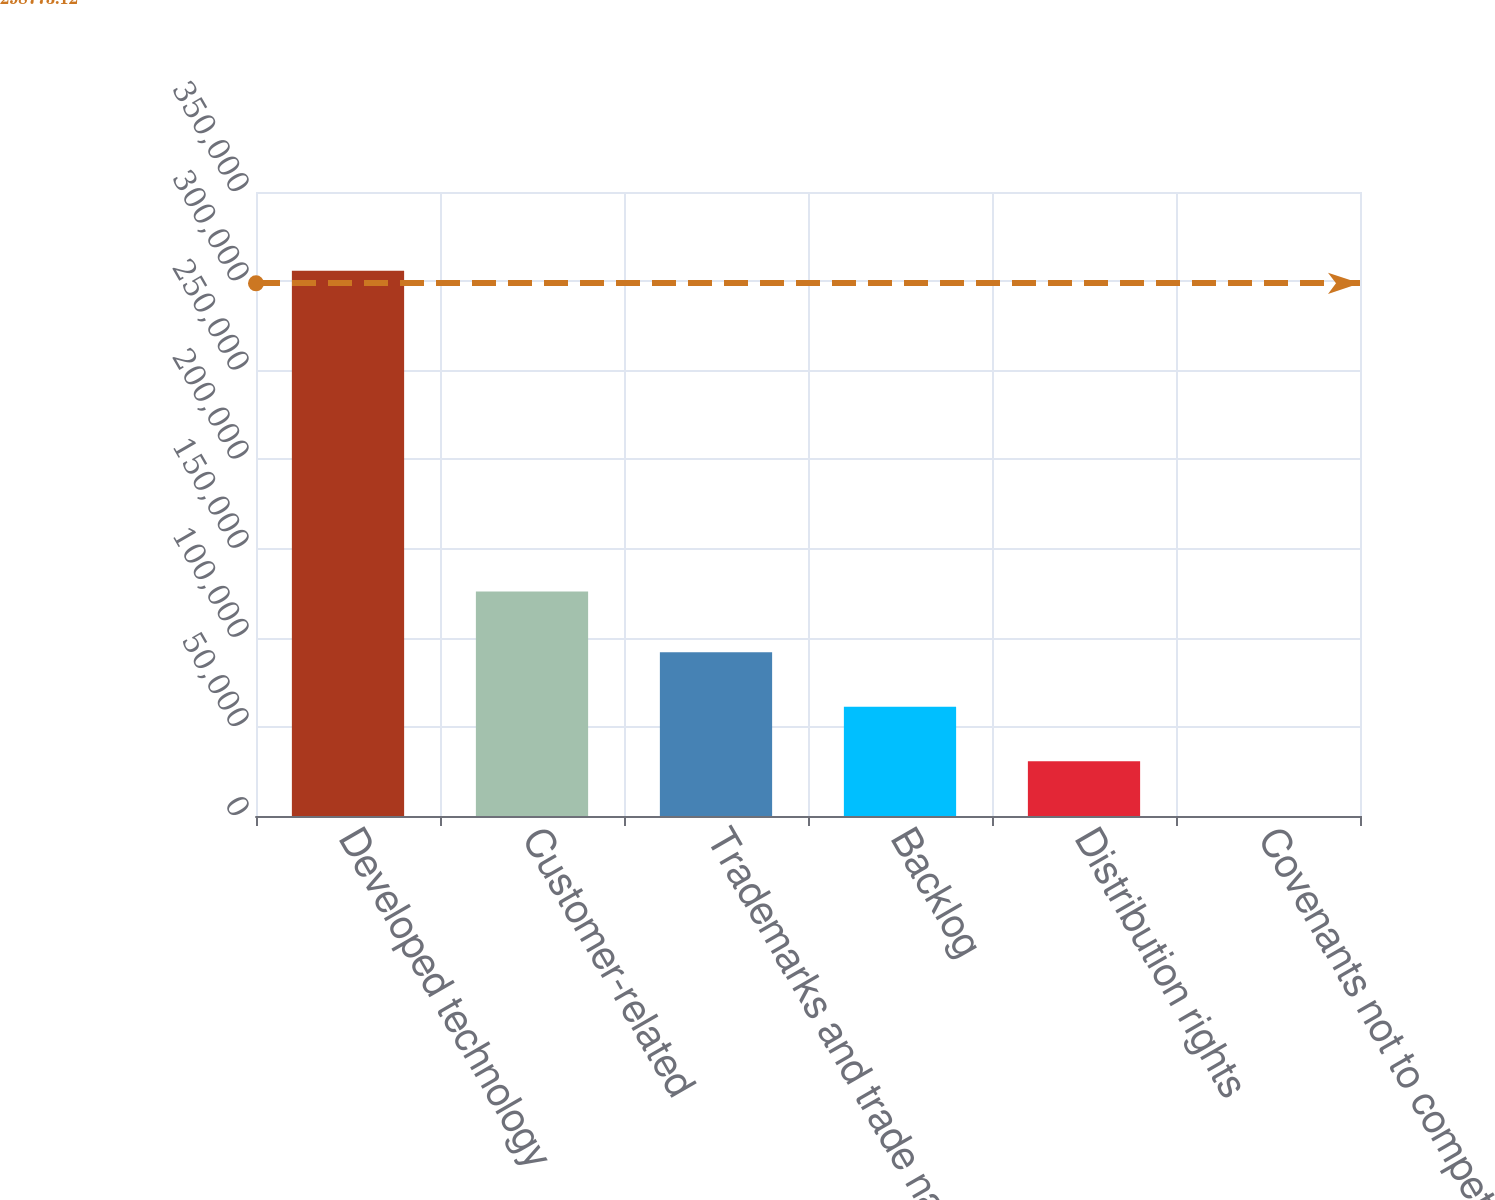<chart> <loc_0><loc_0><loc_500><loc_500><bar_chart><fcel>Developed technology<fcel>Customer-related<fcel>Trademarks and trade names<fcel>Backlog<fcel>Distribution rights<fcel>Covenants not to compete<nl><fcel>305899<fcel>125978<fcel>91816.6<fcel>61233.4<fcel>30650.2<fcel>67<nl></chart> 